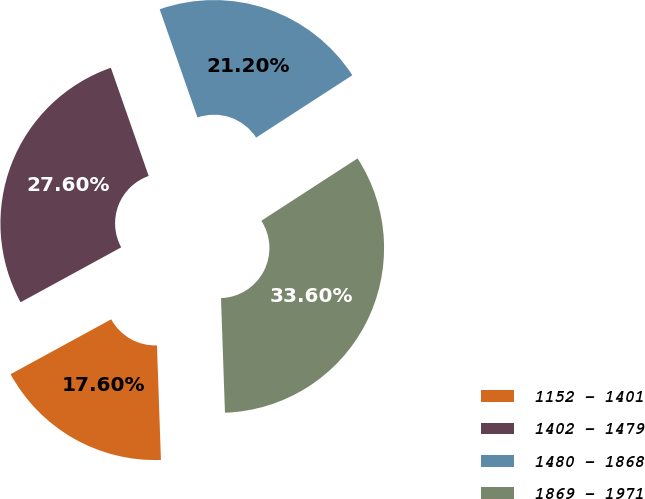Convert chart to OTSL. <chart><loc_0><loc_0><loc_500><loc_500><pie_chart><fcel>1152 - 1401<fcel>1402 - 1479<fcel>1480 - 1868<fcel>1869 - 1971<nl><fcel>17.6%<fcel>27.6%<fcel>21.2%<fcel>33.6%<nl></chart> 